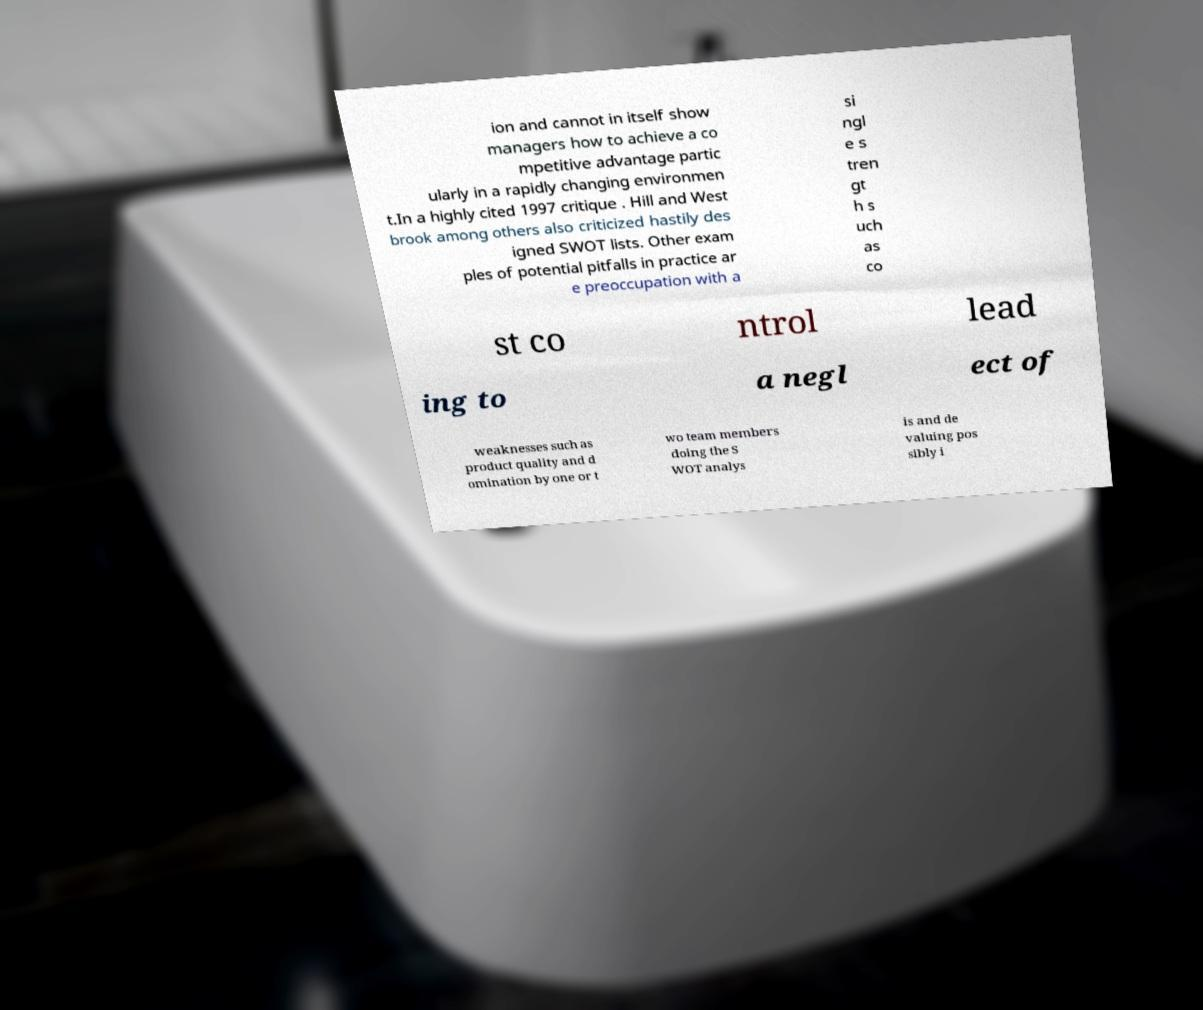Can you accurately transcribe the text from the provided image for me? ion and cannot in itself show managers how to achieve a co mpetitive advantage partic ularly in a rapidly changing environmen t.In a highly cited 1997 critique . Hill and West brook among others also criticized hastily des igned SWOT lists. Other exam ples of potential pitfalls in practice ar e preoccupation with a si ngl e s tren gt h s uch as co st co ntrol lead ing to a negl ect of weaknesses such as product quality and d omination by one or t wo team members doing the S WOT analys is and de valuing pos sibly i 